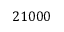Convert formula to latex. <formula><loc_0><loc_0><loc_500><loc_500>2 1 0 0 0</formula> 